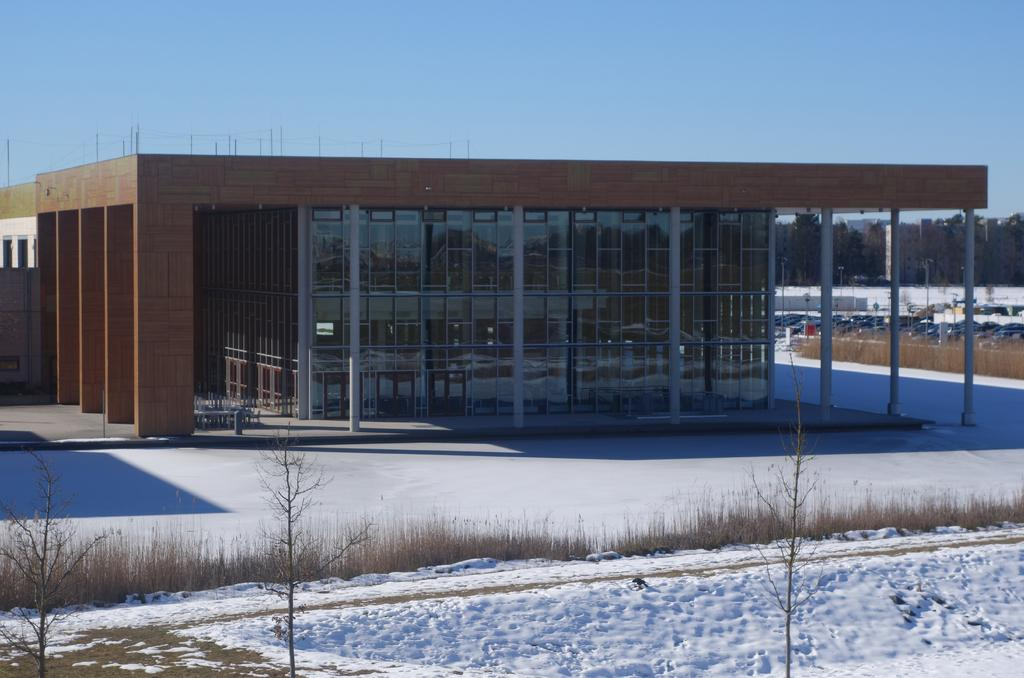What is the main structure visible in the image? There is a building in the image. What is covering the ground in front of the building? There is snow in front of the building. Where are the vehicles located in the image? The vehicles are in the right corner of the image. What type of animal can be seen inside the building in the image? There is no animal visible inside the building in the image. 